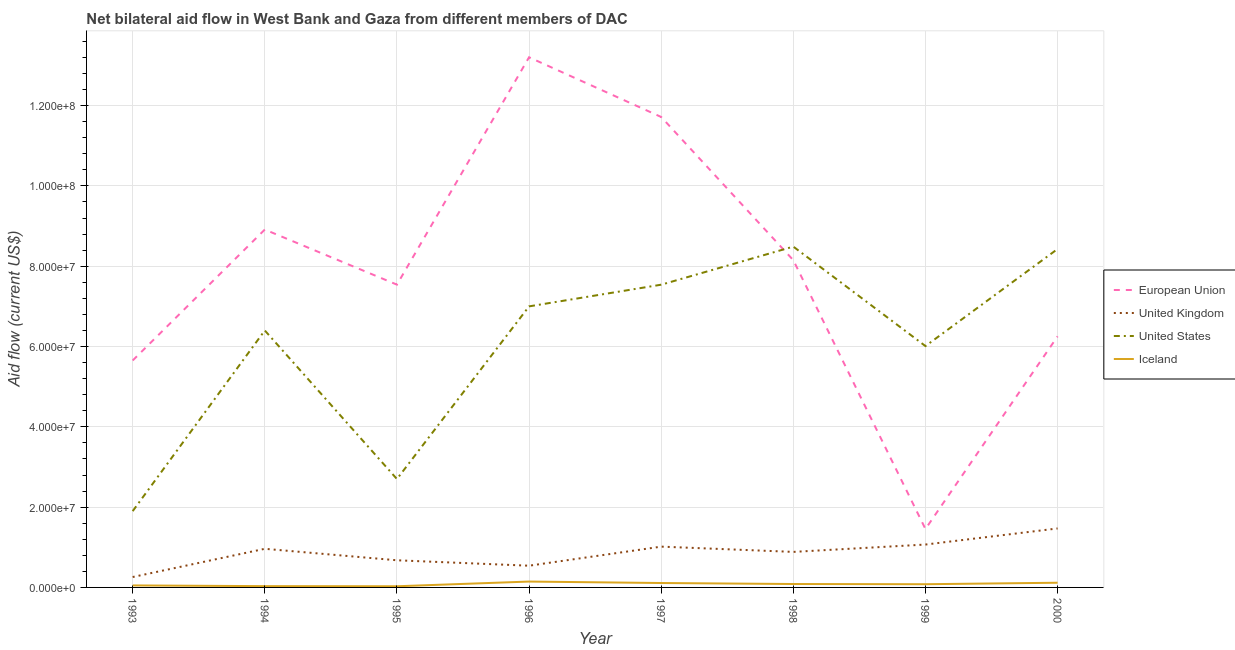Does the line corresponding to amount of aid given by eu intersect with the line corresponding to amount of aid given by iceland?
Your response must be concise. No. Is the number of lines equal to the number of legend labels?
Your answer should be very brief. Yes. What is the amount of aid given by uk in 1997?
Ensure brevity in your answer.  1.02e+07. Across all years, what is the maximum amount of aid given by eu?
Keep it short and to the point. 1.32e+08. Across all years, what is the minimum amount of aid given by uk?
Offer a very short reply. 2.59e+06. In which year was the amount of aid given by eu maximum?
Keep it short and to the point. 1996. In which year was the amount of aid given by iceland minimum?
Offer a very short reply. 1995. What is the total amount of aid given by uk in the graph?
Give a very brief answer. 6.88e+07. What is the difference between the amount of aid given by us in 1994 and that in 1997?
Provide a short and direct response. -1.14e+07. What is the difference between the amount of aid given by uk in 1999 and the amount of aid given by iceland in 1998?
Ensure brevity in your answer.  9.83e+06. What is the average amount of aid given by uk per year?
Keep it short and to the point. 8.60e+06. In the year 1997, what is the difference between the amount of aid given by uk and amount of aid given by us?
Provide a short and direct response. -6.52e+07. What is the ratio of the amount of aid given by us in 1993 to that in 1994?
Offer a very short reply. 0.3. What is the difference between the highest and the second highest amount of aid given by uk?
Your answer should be very brief. 4.01e+06. What is the difference between the highest and the lowest amount of aid given by iceland?
Your answer should be very brief. 1.17e+06. In how many years, is the amount of aid given by eu greater than the average amount of aid given by eu taken over all years?
Keep it short and to the point. 4. Is the sum of the amount of aid given by uk in 1993 and 1996 greater than the maximum amount of aid given by iceland across all years?
Give a very brief answer. Yes. Is it the case that in every year, the sum of the amount of aid given by eu and amount of aid given by uk is greater than the amount of aid given by us?
Offer a very short reply. No. Does the amount of aid given by uk monotonically increase over the years?
Offer a terse response. No. Is the amount of aid given by eu strictly greater than the amount of aid given by us over the years?
Make the answer very short. No. Is the amount of aid given by eu strictly less than the amount of aid given by uk over the years?
Provide a succinct answer. No. How many lines are there?
Offer a terse response. 4. What is the difference between two consecutive major ticks on the Y-axis?
Give a very brief answer. 2.00e+07. Does the graph contain any zero values?
Ensure brevity in your answer.  No. Where does the legend appear in the graph?
Offer a very short reply. Center right. How many legend labels are there?
Make the answer very short. 4. What is the title of the graph?
Keep it short and to the point. Net bilateral aid flow in West Bank and Gaza from different members of DAC. What is the label or title of the Y-axis?
Ensure brevity in your answer.  Aid flow (current US$). What is the Aid flow (current US$) of European Union in 1993?
Provide a succinct answer. 5.65e+07. What is the Aid flow (current US$) of United Kingdom in 1993?
Keep it short and to the point. 2.59e+06. What is the Aid flow (current US$) of United States in 1993?
Keep it short and to the point. 1.90e+07. What is the Aid flow (current US$) in European Union in 1994?
Keep it short and to the point. 8.91e+07. What is the Aid flow (current US$) of United Kingdom in 1994?
Your response must be concise. 9.62e+06. What is the Aid flow (current US$) of United States in 1994?
Offer a very short reply. 6.40e+07. What is the Aid flow (current US$) in European Union in 1995?
Your answer should be compact. 7.54e+07. What is the Aid flow (current US$) of United Kingdom in 1995?
Ensure brevity in your answer.  6.76e+06. What is the Aid flow (current US$) of United States in 1995?
Offer a very short reply. 2.70e+07. What is the Aid flow (current US$) of Iceland in 1995?
Your response must be concise. 2.90e+05. What is the Aid flow (current US$) in European Union in 1996?
Your response must be concise. 1.32e+08. What is the Aid flow (current US$) of United Kingdom in 1996?
Your answer should be very brief. 5.41e+06. What is the Aid flow (current US$) in United States in 1996?
Offer a terse response. 7.00e+07. What is the Aid flow (current US$) of Iceland in 1996?
Your response must be concise. 1.46e+06. What is the Aid flow (current US$) of European Union in 1997?
Ensure brevity in your answer.  1.17e+08. What is the Aid flow (current US$) in United Kingdom in 1997?
Give a very brief answer. 1.02e+07. What is the Aid flow (current US$) in United States in 1997?
Provide a succinct answer. 7.54e+07. What is the Aid flow (current US$) in Iceland in 1997?
Your answer should be very brief. 1.10e+06. What is the Aid flow (current US$) in European Union in 1998?
Make the answer very short. 8.15e+07. What is the Aid flow (current US$) of United Kingdom in 1998?
Offer a very short reply. 8.85e+06. What is the Aid flow (current US$) of United States in 1998?
Keep it short and to the point. 8.49e+07. What is the Aid flow (current US$) of Iceland in 1998?
Provide a short and direct response. 8.50e+05. What is the Aid flow (current US$) in European Union in 1999?
Your response must be concise. 1.46e+07. What is the Aid flow (current US$) in United Kingdom in 1999?
Give a very brief answer. 1.07e+07. What is the Aid flow (current US$) of United States in 1999?
Offer a terse response. 6.01e+07. What is the Aid flow (current US$) of Iceland in 1999?
Your answer should be compact. 8.00e+05. What is the Aid flow (current US$) in European Union in 2000?
Ensure brevity in your answer.  6.25e+07. What is the Aid flow (current US$) in United Kingdom in 2000?
Provide a succinct answer. 1.47e+07. What is the Aid flow (current US$) in United States in 2000?
Your answer should be very brief. 8.43e+07. What is the Aid flow (current US$) in Iceland in 2000?
Provide a succinct answer. 1.17e+06. Across all years, what is the maximum Aid flow (current US$) in European Union?
Offer a terse response. 1.32e+08. Across all years, what is the maximum Aid flow (current US$) of United Kingdom?
Offer a very short reply. 1.47e+07. Across all years, what is the maximum Aid flow (current US$) of United States?
Offer a very short reply. 8.49e+07. Across all years, what is the maximum Aid flow (current US$) in Iceland?
Your answer should be compact. 1.46e+06. Across all years, what is the minimum Aid flow (current US$) of European Union?
Provide a short and direct response. 1.46e+07. Across all years, what is the minimum Aid flow (current US$) of United Kingdom?
Make the answer very short. 2.59e+06. Across all years, what is the minimum Aid flow (current US$) of United States?
Provide a short and direct response. 1.90e+07. Across all years, what is the minimum Aid flow (current US$) in Iceland?
Ensure brevity in your answer.  2.90e+05. What is the total Aid flow (current US$) of European Union in the graph?
Give a very brief answer. 6.29e+08. What is the total Aid flow (current US$) of United Kingdom in the graph?
Provide a succinct answer. 6.88e+07. What is the total Aid flow (current US$) in United States in the graph?
Your answer should be very brief. 4.85e+08. What is the total Aid flow (current US$) in Iceland in the graph?
Make the answer very short. 6.49e+06. What is the difference between the Aid flow (current US$) of European Union in 1993 and that in 1994?
Your response must be concise. -3.26e+07. What is the difference between the Aid flow (current US$) of United Kingdom in 1993 and that in 1994?
Give a very brief answer. -7.03e+06. What is the difference between the Aid flow (current US$) of United States in 1993 and that in 1994?
Offer a very short reply. -4.50e+07. What is the difference between the Aid flow (current US$) of Iceland in 1993 and that in 1994?
Ensure brevity in your answer.  1.80e+05. What is the difference between the Aid flow (current US$) in European Union in 1993 and that in 1995?
Provide a short and direct response. -1.89e+07. What is the difference between the Aid flow (current US$) in United Kingdom in 1993 and that in 1995?
Ensure brevity in your answer.  -4.17e+06. What is the difference between the Aid flow (current US$) in United States in 1993 and that in 1995?
Keep it short and to the point. -8.00e+06. What is the difference between the Aid flow (current US$) of Iceland in 1993 and that in 1995?
Make the answer very short. 2.10e+05. What is the difference between the Aid flow (current US$) in European Union in 1993 and that in 1996?
Make the answer very short. -7.55e+07. What is the difference between the Aid flow (current US$) of United Kingdom in 1993 and that in 1996?
Your answer should be very brief. -2.82e+06. What is the difference between the Aid flow (current US$) in United States in 1993 and that in 1996?
Provide a succinct answer. -5.10e+07. What is the difference between the Aid flow (current US$) in Iceland in 1993 and that in 1996?
Provide a short and direct response. -9.60e+05. What is the difference between the Aid flow (current US$) in European Union in 1993 and that in 1997?
Give a very brief answer. -6.06e+07. What is the difference between the Aid flow (current US$) in United Kingdom in 1993 and that in 1997?
Your answer should be very brief. -7.57e+06. What is the difference between the Aid flow (current US$) of United States in 1993 and that in 1997?
Provide a short and direct response. -5.64e+07. What is the difference between the Aid flow (current US$) of Iceland in 1993 and that in 1997?
Your answer should be very brief. -6.00e+05. What is the difference between the Aid flow (current US$) of European Union in 1993 and that in 1998?
Offer a very short reply. -2.50e+07. What is the difference between the Aid flow (current US$) in United Kingdom in 1993 and that in 1998?
Give a very brief answer. -6.26e+06. What is the difference between the Aid flow (current US$) in United States in 1993 and that in 1998?
Offer a very short reply. -6.59e+07. What is the difference between the Aid flow (current US$) in Iceland in 1993 and that in 1998?
Keep it short and to the point. -3.50e+05. What is the difference between the Aid flow (current US$) of European Union in 1993 and that in 1999?
Offer a very short reply. 4.20e+07. What is the difference between the Aid flow (current US$) of United Kingdom in 1993 and that in 1999?
Your answer should be very brief. -8.09e+06. What is the difference between the Aid flow (current US$) in United States in 1993 and that in 1999?
Offer a very short reply. -4.11e+07. What is the difference between the Aid flow (current US$) of Iceland in 1993 and that in 1999?
Provide a succinct answer. -3.00e+05. What is the difference between the Aid flow (current US$) of European Union in 1993 and that in 2000?
Offer a very short reply. -6.01e+06. What is the difference between the Aid flow (current US$) of United Kingdom in 1993 and that in 2000?
Provide a succinct answer. -1.21e+07. What is the difference between the Aid flow (current US$) of United States in 1993 and that in 2000?
Ensure brevity in your answer.  -6.53e+07. What is the difference between the Aid flow (current US$) of Iceland in 1993 and that in 2000?
Ensure brevity in your answer.  -6.70e+05. What is the difference between the Aid flow (current US$) in European Union in 1994 and that in 1995?
Your answer should be very brief. 1.37e+07. What is the difference between the Aid flow (current US$) in United Kingdom in 1994 and that in 1995?
Provide a succinct answer. 2.86e+06. What is the difference between the Aid flow (current US$) of United States in 1994 and that in 1995?
Provide a short and direct response. 3.70e+07. What is the difference between the Aid flow (current US$) of Iceland in 1994 and that in 1995?
Make the answer very short. 3.00e+04. What is the difference between the Aid flow (current US$) in European Union in 1994 and that in 1996?
Your answer should be compact. -4.29e+07. What is the difference between the Aid flow (current US$) in United Kingdom in 1994 and that in 1996?
Provide a succinct answer. 4.21e+06. What is the difference between the Aid flow (current US$) of United States in 1994 and that in 1996?
Keep it short and to the point. -6.00e+06. What is the difference between the Aid flow (current US$) in Iceland in 1994 and that in 1996?
Ensure brevity in your answer.  -1.14e+06. What is the difference between the Aid flow (current US$) of European Union in 1994 and that in 1997?
Make the answer very short. -2.80e+07. What is the difference between the Aid flow (current US$) of United Kingdom in 1994 and that in 1997?
Provide a short and direct response. -5.40e+05. What is the difference between the Aid flow (current US$) in United States in 1994 and that in 1997?
Your answer should be very brief. -1.14e+07. What is the difference between the Aid flow (current US$) of Iceland in 1994 and that in 1997?
Give a very brief answer. -7.80e+05. What is the difference between the Aid flow (current US$) of European Union in 1994 and that in 1998?
Your response must be concise. 7.63e+06. What is the difference between the Aid flow (current US$) of United Kingdom in 1994 and that in 1998?
Make the answer very short. 7.70e+05. What is the difference between the Aid flow (current US$) of United States in 1994 and that in 1998?
Make the answer very short. -2.09e+07. What is the difference between the Aid flow (current US$) of Iceland in 1994 and that in 1998?
Give a very brief answer. -5.30e+05. What is the difference between the Aid flow (current US$) of European Union in 1994 and that in 1999?
Your answer should be compact. 7.46e+07. What is the difference between the Aid flow (current US$) of United Kingdom in 1994 and that in 1999?
Your answer should be compact. -1.06e+06. What is the difference between the Aid flow (current US$) in United States in 1994 and that in 1999?
Make the answer very short. 3.89e+06. What is the difference between the Aid flow (current US$) of Iceland in 1994 and that in 1999?
Provide a short and direct response. -4.80e+05. What is the difference between the Aid flow (current US$) in European Union in 1994 and that in 2000?
Provide a short and direct response. 2.66e+07. What is the difference between the Aid flow (current US$) in United Kingdom in 1994 and that in 2000?
Keep it short and to the point. -5.07e+06. What is the difference between the Aid flow (current US$) of United States in 1994 and that in 2000?
Make the answer very short. -2.03e+07. What is the difference between the Aid flow (current US$) of Iceland in 1994 and that in 2000?
Provide a succinct answer. -8.50e+05. What is the difference between the Aid flow (current US$) in European Union in 1995 and that in 1996?
Keep it short and to the point. -5.66e+07. What is the difference between the Aid flow (current US$) in United Kingdom in 1995 and that in 1996?
Provide a short and direct response. 1.35e+06. What is the difference between the Aid flow (current US$) in United States in 1995 and that in 1996?
Make the answer very short. -4.30e+07. What is the difference between the Aid flow (current US$) in Iceland in 1995 and that in 1996?
Provide a short and direct response. -1.17e+06. What is the difference between the Aid flow (current US$) in European Union in 1995 and that in 1997?
Give a very brief answer. -4.18e+07. What is the difference between the Aid flow (current US$) of United Kingdom in 1995 and that in 1997?
Ensure brevity in your answer.  -3.40e+06. What is the difference between the Aid flow (current US$) in United States in 1995 and that in 1997?
Your response must be concise. -4.84e+07. What is the difference between the Aid flow (current US$) of Iceland in 1995 and that in 1997?
Your response must be concise. -8.10e+05. What is the difference between the Aid flow (current US$) in European Union in 1995 and that in 1998?
Your response must be concise. -6.09e+06. What is the difference between the Aid flow (current US$) of United Kingdom in 1995 and that in 1998?
Offer a very short reply. -2.09e+06. What is the difference between the Aid flow (current US$) of United States in 1995 and that in 1998?
Provide a short and direct response. -5.79e+07. What is the difference between the Aid flow (current US$) in Iceland in 1995 and that in 1998?
Give a very brief answer. -5.60e+05. What is the difference between the Aid flow (current US$) of European Union in 1995 and that in 1999?
Keep it short and to the point. 6.09e+07. What is the difference between the Aid flow (current US$) in United Kingdom in 1995 and that in 1999?
Provide a short and direct response. -3.92e+06. What is the difference between the Aid flow (current US$) in United States in 1995 and that in 1999?
Your answer should be compact. -3.31e+07. What is the difference between the Aid flow (current US$) of Iceland in 1995 and that in 1999?
Keep it short and to the point. -5.10e+05. What is the difference between the Aid flow (current US$) of European Union in 1995 and that in 2000?
Give a very brief answer. 1.29e+07. What is the difference between the Aid flow (current US$) in United Kingdom in 1995 and that in 2000?
Ensure brevity in your answer.  -7.93e+06. What is the difference between the Aid flow (current US$) of United States in 1995 and that in 2000?
Offer a very short reply. -5.73e+07. What is the difference between the Aid flow (current US$) in Iceland in 1995 and that in 2000?
Ensure brevity in your answer.  -8.80e+05. What is the difference between the Aid flow (current US$) of European Union in 1996 and that in 1997?
Your answer should be compact. 1.49e+07. What is the difference between the Aid flow (current US$) of United Kingdom in 1996 and that in 1997?
Give a very brief answer. -4.75e+06. What is the difference between the Aid flow (current US$) of United States in 1996 and that in 1997?
Offer a very short reply. -5.40e+06. What is the difference between the Aid flow (current US$) in Iceland in 1996 and that in 1997?
Your answer should be compact. 3.60e+05. What is the difference between the Aid flow (current US$) of European Union in 1996 and that in 1998?
Make the answer very short. 5.05e+07. What is the difference between the Aid flow (current US$) in United Kingdom in 1996 and that in 1998?
Your response must be concise. -3.44e+06. What is the difference between the Aid flow (current US$) in United States in 1996 and that in 1998?
Make the answer very short. -1.49e+07. What is the difference between the Aid flow (current US$) of Iceland in 1996 and that in 1998?
Ensure brevity in your answer.  6.10e+05. What is the difference between the Aid flow (current US$) of European Union in 1996 and that in 1999?
Provide a succinct answer. 1.17e+08. What is the difference between the Aid flow (current US$) of United Kingdom in 1996 and that in 1999?
Offer a terse response. -5.27e+06. What is the difference between the Aid flow (current US$) of United States in 1996 and that in 1999?
Give a very brief answer. 9.89e+06. What is the difference between the Aid flow (current US$) of Iceland in 1996 and that in 1999?
Provide a succinct answer. 6.60e+05. What is the difference between the Aid flow (current US$) of European Union in 1996 and that in 2000?
Make the answer very short. 6.95e+07. What is the difference between the Aid flow (current US$) in United Kingdom in 1996 and that in 2000?
Provide a short and direct response. -9.28e+06. What is the difference between the Aid flow (current US$) of United States in 1996 and that in 2000?
Offer a terse response. -1.43e+07. What is the difference between the Aid flow (current US$) of Iceland in 1996 and that in 2000?
Offer a very short reply. 2.90e+05. What is the difference between the Aid flow (current US$) in European Union in 1997 and that in 1998?
Offer a terse response. 3.57e+07. What is the difference between the Aid flow (current US$) in United Kingdom in 1997 and that in 1998?
Give a very brief answer. 1.31e+06. What is the difference between the Aid flow (current US$) in United States in 1997 and that in 1998?
Give a very brief answer. -9.48e+06. What is the difference between the Aid flow (current US$) of Iceland in 1997 and that in 1998?
Ensure brevity in your answer.  2.50e+05. What is the difference between the Aid flow (current US$) in European Union in 1997 and that in 1999?
Provide a short and direct response. 1.03e+08. What is the difference between the Aid flow (current US$) in United Kingdom in 1997 and that in 1999?
Give a very brief answer. -5.20e+05. What is the difference between the Aid flow (current US$) of United States in 1997 and that in 1999?
Offer a very short reply. 1.53e+07. What is the difference between the Aid flow (current US$) in European Union in 1997 and that in 2000?
Keep it short and to the point. 5.46e+07. What is the difference between the Aid flow (current US$) of United Kingdom in 1997 and that in 2000?
Your answer should be very brief. -4.53e+06. What is the difference between the Aid flow (current US$) in United States in 1997 and that in 2000?
Provide a succinct answer. -8.89e+06. What is the difference between the Aid flow (current US$) in Iceland in 1997 and that in 2000?
Ensure brevity in your answer.  -7.00e+04. What is the difference between the Aid flow (current US$) in European Union in 1998 and that in 1999?
Your response must be concise. 6.70e+07. What is the difference between the Aid flow (current US$) of United Kingdom in 1998 and that in 1999?
Keep it short and to the point. -1.83e+06. What is the difference between the Aid flow (current US$) of United States in 1998 and that in 1999?
Make the answer very short. 2.48e+07. What is the difference between the Aid flow (current US$) of European Union in 1998 and that in 2000?
Make the answer very short. 1.90e+07. What is the difference between the Aid flow (current US$) in United Kingdom in 1998 and that in 2000?
Your response must be concise. -5.84e+06. What is the difference between the Aid flow (current US$) of United States in 1998 and that in 2000?
Your answer should be very brief. 5.90e+05. What is the difference between the Aid flow (current US$) of Iceland in 1998 and that in 2000?
Provide a short and direct response. -3.20e+05. What is the difference between the Aid flow (current US$) of European Union in 1999 and that in 2000?
Your answer should be very brief. -4.80e+07. What is the difference between the Aid flow (current US$) of United Kingdom in 1999 and that in 2000?
Give a very brief answer. -4.01e+06. What is the difference between the Aid flow (current US$) of United States in 1999 and that in 2000?
Offer a terse response. -2.42e+07. What is the difference between the Aid flow (current US$) in Iceland in 1999 and that in 2000?
Your response must be concise. -3.70e+05. What is the difference between the Aid flow (current US$) in European Union in 1993 and the Aid flow (current US$) in United Kingdom in 1994?
Keep it short and to the point. 4.69e+07. What is the difference between the Aid flow (current US$) of European Union in 1993 and the Aid flow (current US$) of United States in 1994?
Ensure brevity in your answer.  -7.48e+06. What is the difference between the Aid flow (current US$) of European Union in 1993 and the Aid flow (current US$) of Iceland in 1994?
Your response must be concise. 5.62e+07. What is the difference between the Aid flow (current US$) of United Kingdom in 1993 and the Aid flow (current US$) of United States in 1994?
Your answer should be very brief. -6.14e+07. What is the difference between the Aid flow (current US$) of United Kingdom in 1993 and the Aid flow (current US$) of Iceland in 1994?
Offer a very short reply. 2.27e+06. What is the difference between the Aid flow (current US$) of United States in 1993 and the Aid flow (current US$) of Iceland in 1994?
Offer a very short reply. 1.87e+07. What is the difference between the Aid flow (current US$) of European Union in 1993 and the Aid flow (current US$) of United Kingdom in 1995?
Give a very brief answer. 4.98e+07. What is the difference between the Aid flow (current US$) in European Union in 1993 and the Aid flow (current US$) in United States in 1995?
Keep it short and to the point. 2.95e+07. What is the difference between the Aid flow (current US$) of European Union in 1993 and the Aid flow (current US$) of Iceland in 1995?
Your answer should be very brief. 5.62e+07. What is the difference between the Aid flow (current US$) of United Kingdom in 1993 and the Aid flow (current US$) of United States in 1995?
Provide a succinct answer. -2.44e+07. What is the difference between the Aid flow (current US$) of United Kingdom in 1993 and the Aid flow (current US$) of Iceland in 1995?
Your response must be concise. 2.30e+06. What is the difference between the Aid flow (current US$) of United States in 1993 and the Aid flow (current US$) of Iceland in 1995?
Offer a terse response. 1.87e+07. What is the difference between the Aid flow (current US$) in European Union in 1993 and the Aid flow (current US$) in United Kingdom in 1996?
Offer a very short reply. 5.11e+07. What is the difference between the Aid flow (current US$) in European Union in 1993 and the Aid flow (current US$) in United States in 1996?
Your answer should be compact. -1.35e+07. What is the difference between the Aid flow (current US$) of European Union in 1993 and the Aid flow (current US$) of Iceland in 1996?
Offer a very short reply. 5.51e+07. What is the difference between the Aid flow (current US$) in United Kingdom in 1993 and the Aid flow (current US$) in United States in 1996?
Provide a short and direct response. -6.74e+07. What is the difference between the Aid flow (current US$) of United Kingdom in 1993 and the Aid flow (current US$) of Iceland in 1996?
Your answer should be very brief. 1.13e+06. What is the difference between the Aid flow (current US$) in United States in 1993 and the Aid flow (current US$) in Iceland in 1996?
Provide a short and direct response. 1.75e+07. What is the difference between the Aid flow (current US$) in European Union in 1993 and the Aid flow (current US$) in United Kingdom in 1997?
Offer a very short reply. 4.64e+07. What is the difference between the Aid flow (current US$) of European Union in 1993 and the Aid flow (current US$) of United States in 1997?
Your answer should be very brief. -1.89e+07. What is the difference between the Aid flow (current US$) in European Union in 1993 and the Aid flow (current US$) in Iceland in 1997?
Offer a terse response. 5.54e+07. What is the difference between the Aid flow (current US$) of United Kingdom in 1993 and the Aid flow (current US$) of United States in 1997?
Make the answer very short. -7.28e+07. What is the difference between the Aid flow (current US$) of United Kingdom in 1993 and the Aid flow (current US$) of Iceland in 1997?
Ensure brevity in your answer.  1.49e+06. What is the difference between the Aid flow (current US$) in United States in 1993 and the Aid flow (current US$) in Iceland in 1997?
Your response must be concise. 1.79e+07. What is the difference between the Aid flow (current US$) in European Union in 1993 and the Aid flow (current US$) in United Kingdom in 1998?
Offer a very short reply. 4.77e+07. What is the difference between the Aid flow (current US$) in European Union in 1993 and the Aid flow (current US$) in United States in 1998?
Offer a terse response. -2.84e+07. What is the difference between the Aid flow (current US$) in European Union in 1993 and the Aid flow (current US$) in Iceland in 1998?
Ensure brevity in your answer.  5.57e+07. What is the difference between the Aid flow (current US$) in United Kingdom in 1993 and the Aid flow (current US$) in United States in 1998?
Provide a short and direct response. -8.23e+07. What is the difference between the Aid flow (current US$) in United Kingdom in 1993 and the Aid flow (current US$) in Iceland in 1998?
Keep it short and to the point. 1.74e+06. What is the difference between the Aid flow (current US$) of United States in 1993 and the Aid flow (current US$) of Iceland in 1998?
Give a very brief answer. 1.82e+07. What is the difference between the Aid flow (current US$) of European Union in 1993 and the Aid flow (current US$) of United Kingdom in 1999?
Provide a short and direct response. 4.58e+07. What is the difference between the Aid flow (current US$) of European Union in 1993 and the Aid flow (current US$) of United States in 1999?
Your answer should be very brief. -3.59e+06. What is the difference between the Aid flow (current US$) of European Union in 1993 and the Aid flow (current US$) of Iceland in 1999?
Offer a very short reply. 5.57e+07. What is the difference between the Aid flow (current US$) of United Kingdom in 1993 and the Aid flow (current US$) of United States in 1999?
Your response must be concise. -5.75e+07. What is the difference between the Aid flow (current US$) in United Kingdom in 1993 and the Aid flow (current US$) in Iceland in 1999?
Provide a short and direct response. 1.79e+06. What is the difference between the Aid flow (current US$) of United States in 1993 and the Aid flow (current US$) of Iceland in 1999?
Give a very brief answer. 1.82e+07. What is the difference between the Aid flow (current US$) of European Union in 1993 and the Aid flow (current US$) of United Kingdom in 2000?
Your answer should be very brief. 4.18e+07. What is the difference between the Aid flow (current US$) in European Union in 1993 and the Aid flow (current US$) in United States in 2000?
Your answer should be compact. -2.78e+07. What is the difference between the Aid flow (current US$) of European Union in 1993 and the Aid flow (current US$) of Iceland in 2000?
Offer a terse response. 5.54e+07. What is the difference between the Aid flow (current US$) in United Kingdom in 1993 and the Aid flow (current US$) in United States in 2000?
Your response must be concise. -8.17e+07. What is the difference between the Aid flow (current US$) of United Kingdom in 1993 and the Aid flow (current US$) of Iceland in 2000?
Your response must be concise. 1.42e+06. What is the difference between the Aid flow (current US$) in United States in 1993 and the Aid flow (current US$) in Iceland in 2000?
Give a very brief answer. 1.78e+07. What is the difference between the Aid flow (current US$) in European Union in 1994 and the Aid flow (current US$) in United Kingdom in 1995?
Your answer should be very brief. 8.24e+07. What is the difference between the Aid flow (current US$) of European Union in 1994 and the Aid flow (current US$) of United States in 1995?
Provide a succinct answer. 6.21e+07. What is the difference between the Aid flow (current US$) in European Union in 1994 and the Aid flow (current US$) in Iceland in 1995?
Offer a very short reply. 8.88e+07. What is the difference between the Aid flow (current US$) of United Kingdom in 1994 and the Aid flow (current US$) of United States in 1995?
Make the answer very short. -1.74e+07. What is the difference between the Aid flow (current US$) in United Kingdom in 1994 and the Aid flow (current US$) in Iceland in 1995?
Give a very brief answer. 9.33e+06. What is the difference between the Aid flow (current US$) of United States in 1994 and the Aid flow (current US$) of Iceland in 1995?
Make the answer very short. 6.37e+07. What is the difference between the Aid flow (current US$) of European Union in 1994 and the Aid flow (current US$) of United Kingdom in 1996?
Keep it short and to the point. 8.37e+07. What is the difference between the Aid flow (current US$) of European Union in 1994 and the Aid flow (current US$) of United States in 1996?
Your response must be concise. 1.91e+07. What is the difference between the Aid flow (current US$) in European Union in 1994 and the Aid flow (current US$) in Iceland in 1996?
Provide a short and direct response. 8.77e+07. What is the difference between the Aid flow (current US$) in United Kingdom in 1994 and the Aid flow (current US$) in United States in 1996?
Your answer should be very brief. -6.04e+07. What is the difference between the Aid flow (current US$) of United Kingdom in 1994 and the Aid flow (current US$) of Iceland in 1996?
Offer a very short reply. 8.16e+06. What is the difference between the Aid flow (current US$) of United States in 1994 and the Aid flow (current US$) of Iceland in 1996?
Your answer should be compact. 6.25e+07. What is the difference between the Aid flow (current US$) in European Union in 1994 and the Aid flow (current US$) in United Kingdom in 1997?
Your answer should be compact. 7.90e+07. What is the difference between the Aid flow (current US$) in European Union in 1994 and the Aid flow (current US$) in United States in 1997?
Ensure brevity in your answer.  1.37e+07. What is the difference between the Aid flow (current US$) of European Union in 1994 and the Aid flow (current US$) of Iceland in 1997?
Provide a succinct answer. 8.80e+07. What is the difference between the Aid flow (current US$) in United Kingdom in 1994 and the Aid flow (current US$) in United States in 1997?
Give a very brief answer. -6.58e+07. What is the difference between the Aid flow (current US$) in United Kingdom in 1994 and the Aid flow (current US$) in Iceland in 1997?
Offer a terse response. 8.52e+06. What is the difference between the Aid flow (current US$) of United States in 1994 and the Aid flow (current US$) of Iceland in 1997?
Provide a succinct answer. 6.29e+07. What is the difference between the Aid flow (current US$) of European Union in 1994 and the Aid flow (current US$) of United Kingdom in 1998?
Give a very brief answer. 8.03e+07. What is the difference between the Aid flow (current US$) in European Union in 1994 and the Aid flow (current US$) in United States in 1998?
Offer a terse response. 4.25e+06. What is the difference between the Aid flow (current US$) in European Union in 1994 and the Aid flow (current US$) in Iceland in 1998?
Make the answer very short. 8.83e+07. What is the difference between the Aid flow (current US$) in United Kingdom in 1994 and the Aid flow (current US$) in United States in 1998?
Your answer should be very brief. -7.53e+07. What is the difference between the Aid flow (current US$) of United Kingdom in 1994 and the Aid flow (current US$) of Iceland in 1998?
Provide a short and direct response. 8.77e+06. What is the difference between the Aid flow (current US$) in United States in 1994 and the Aid flow (current US$) in Iceland in 1998?
Offer a very short reply. 6.32e+07. What is the difference between the Aid flow (current US$) of European Union in 1994 and the Aid flow (current US$) of United Kingdom in 1999?
Your response must be concise. 7.84e+07. What is the difference between the Aid flow (current US$) of European Union in 1994 and the Aid flow (current US$) of United States in 1999?
Offer a very short reply. 2.90e+07. What is the difference between the Aid flow (current US$) in European Union in 1994 and the Aid flow (current US$) in Iceland in 1999?
Ensure brevity in your answer.  8.83e+07. What is the difference between the Aid flow (current US$) in United Kingdom in 1994 and the Aid flow (current US$) in United States in 1999?
Provide a succinct answer. -5.05e+07. What is the difference between the Aid flow (current US$) of United Kingdom in 1994 and the Aid flow (current US$) of Iceland in 1999?
Provide a succinct answer. 8.82e+06. What is the difference between the Aid flow (current US$) in United States in 1994 and the Aid flow (current US$) in Iceland in 1999?
Give a very brief answer. 6.32e+07. What is the difference between the Aid flow (current US$) in European Union in 1994 and the Aid flow (current US$) in United Kingdom in 2000?
Your response must be concise. 7.44e+07. What is the difference between the Aid flow (current US$) in European Union in 1994 and the Aid flow (current US$) in United States in 2000?
Offer a very short reply. 4.84e+06. What is the difference between the Aid flow (current US$) of European Union in 1994 and the Aid flow (current US$) of Iceland in 2000?
Your response must be concise. 8.80e+07. What is the difference between the Aid flow (current US$) of United Kingdom in 1994 and the Aid flow (current US$) of United States in 2000?
Provide a succinct answer. -7.47e+07. What is the difference between the Aid flow (current US$) of United Kingdom in 1994 and the Aid flow (current US$) of Iceland in 2000?
Your answer should be compact. 8.45e+06. What is the difference between the Aid flow (current US$) of United States in 1994 and the Aid flow (current US$) of Iceland in 2000?
Offer a very short reply. 6.28e+07. What is the difference between the Aid flow (current US$) in European Union in 1995 and the Aid flow (current US$) in United Kingdom in 1996?
Your answer should be compact. 7.00e+07. What is the difference between the Aid flow (current US$) of European Union in 1995 and the Aid flow (current US$) of United States in 1996?
Provide a short and direct response. 5.41e+06. What is the difference between the Aid flow (current US$) of European Union in 1995 and the Aid flow (current US$) of Iceland in 1996?
Give a very brief answer. 7.40e+07. What is the difference between the Aid flow (current US$) of United Kingdom in 1995 and the Aid flow (current US$) of United States in 1996?
Your response must be concise. -6.32e+07. What is the difference between the Aid flow (current US$) of United Kingdom in 1995 and the Aid flow (current US$) of Iceland in 1996?
Your answer should be compact. 5.30e+06. What is the difference between the Aid flow (current US$) of United States in 1995 and the Aid flow (current US$) of Iceland in 1996?
Your response must be concise. 2.55e+07. What is the difference between the Aid flow (current US$) in European Union in 1995 and the Aid flow (current US$) in United Kingdom in 1997?
Offer a terse response. 6.52e+07. What is the difference between the Aid flow (current US$) in European Union in 1995 and the Aid flow (current US$) in Iceland in 1997?
Your answer should be compact. 7.43e+07. What is the difference between the Aid flow (current US$) of United Kingdom in 1995 and the Aid flow (current US$) of United States in 1997?
Offer a very short reply. -6.86e+07. What is the difference between the Aid flow (current US$) in United Kingdom in 1995 and the Aid flow (current US$) in Iceland in 1997?
Give a very brief answer. 5.66e+06. What is the difference between the Aid flow (current US$) in United States in 1995 and the Aid flow (current US$) in Iceland in 1997?
Provide a short and direct response. 2.59e+07. What is the difference between the Aid flow (current US$) of European Union in 1995 and the Aid flow (current US$) of United Kingdom in 1998?
Offer a very short reply. 6.66e+07. What is the difference between the Aid flow (current US$) in European Union in 1995 and the Aid flow (current US$) in United States in 1998?
Your answer should be compact. -9.47e+06. What is the difference between the Aid flow (current US$) of European Union in 1995 and the Aid flow (current US$) of Iceland in 1998?
Make the answer very short. 7.46e+07. What is the difference between the Aid flow (current US$) of United Kingdom in 1995 and the Aid flow (current US$) of United States in 1998?
Your response must be concise. -7.81e+07. What is the difference between the Aid flow (current US$) in United Kingdom in 1995 and the Aid flow (current US$) in Iceland in 1998?
Your response must be concise. 5.91e+06. What is the difference between the Aid flow (current US$) in United States in 1995 and the Aid flow (current US$) in Iceland in 1998?
Provide a succinct answer. 2.62e+07. What is the difference between the Aid flow (current US$) in European Union in 1995 and the Aid flow (current US$) in United Kingdom in 1999?
Your answer should be very brief. 6.47e+07. What is the difference between the Aid flow (current US$) of European Union in 1995 and the Aid flow (current US$) of United States in 1999?
Give a very brief answer. 1.53e+07. What is the difference between the Aid flow (current US$) in European Union in 1995 and the Aid flow (current US$) in Iceland in 1999?
Ensure brevity in your answer.  7.46e+07. What is the difference between the Aid flow (current US$) in United Kingdom in 1995 and the Aid flow (current US$) in United States in 1999?
Your answer should be compact. -5.34e+07. What is the difference between the Aid flow (current US$) in United Kingdom in 1995 and the Aid flow (current US$) in Iceland in 1999?
Your response must be concise. 5.96e+06. What is the difference between the Aid flow (current US$) of United States in 1995 and the Aid flow (current US$) of Iceland in 1999?
Offer a terse response. 2.62e+07. What is the difference between the Aid flow (current US$) of European Union in 1995 and the Aid flow (current US$) of United Kingdom in 2000?
Provide a succinct answer. 6.07e+07. What is the difference between the Aid flow (current US$) in European Union in 1995 and the Aid flow (current US$) in United States in 2000?
Your answer should be compact. -8.88e+06. What is the difference between the Aid flow (current US$) in European Union in 1995 and the Aid flow (current US$) in Iceland in 2000?
Offer a terse response. 7.42e+07. What is the difference between the Aid flow (current US$) of United Kingdom in 1995 and the Aid flow (current US$) of United States in 2000?
Give a very brief answer. -7.75e+07. What is the difference between the Aid flow (current US$) of United Kingdom in 1995 and the Aid flow (current US$) of Iceland in 2000?
Your answer should be compact. 5.59e+06. What is the difference between the Aid flow (current US$) in United States in 1995 and the Aid flow (current US$) in Iceland in 2000?
Provide a short and direct response. 2.58e+07. What is the difference between the Aid flow (current US$) of European Union in 1996 and the Aid flow (current US$) of United Kingdom in 1997?
Keep it short and to the point. 1.22e+08. What is the difference between the Aid flow (current US$) of European Union in 1996 and the Aid flow (current US$) of United States in 1997?
Offer a very short reply. 5.66e+07. What is the difference between the Aid flow (current US$) of European Union in 1996 and the Aid flow (current US$) of Iceland in 1997?
Offer a terse response. 1.31e+08. What is the difference between the Aid flow (current US$) of United Kingdom in 1996 and the Aid flow (current US$) of United States in 1997?
Make the answer very short. -7.00e+07. What is the difference between the Aid flow (current US$) of United Kingdom in 1996 and the Aid flow (current US$) of Iceland in 1997?
Make the answer very short. 4.31e+06. What is the difference between the Aid flow (current US$) in United States in 1996 and the Aid flow (current US$) in Iceland in 1997?
Your answer should be compact. 6.89e+07. What is the difference between the Aid flow (current US$) in European Union in 1996 and the Aid flow (current US$) in United Kingdom in 1998?
Keep it short and to the point. 1.23e+08. What is the difference between the Aid flow (current US$) in European Union in 1996 and the Aid flow (current US$) in United States in 1998?
Your response must be concise. 4.72e+07. What is the difference between the Aid flow (current US$) in European Union in 1996 and the Aid flow (current US$) in Iceland in 1998?
Your answer should be very brief. 1.31e+08. What is the difference between the Aid flow (current US$) of United Kingdom in 1996 and the Aid flow (current US$) of United States in 1998?
Provide a short and direct response. -7.95e+07. What is the difference between the Aid flow (current US$) of United Kingdom in 1996 and the Aid flow (current US$) of Iceland in 1998?
Ensure brevity in your answer.  4.56e+06. What is the difference between the Aid flow (current US$) in United States in 1996 and the Aid flow (current US$) in Iceland in 1998?
Provide a short and direct response. 6.92e+07. What is the difference between the Aid flow (current US$) of European Union in 1996 and the Aid flow (current US$) of United Kingdom in 1999?
Make the answer very short. 1.21e+08. What is the difference between the Aid flow (current US$) in European Union in 1996 and the Aid flow (current US$) in United States in 1999?
Offer a terse response. 7.19e+07. What is the difference between the Aid flow (current US$) in European Union in 1996 and the Aid flow (current US$) in Iceland in 1999?
Provide a short and direct response. 1.31e+08. What is the difference between the Aid flow (current US$) of United Kingdom in 1996 and the Aid flow (current US$) of United States in 1999?
Make the answer very short. -5.47e+07. What is the difference between the Aid flow (current US$) of United Kingdom in 1996 and the Aid flow (current US$) of Iceland in 1999?
Provide a short and direct response. 4.61e+06. What is the difference between the Aid flow (current US$) in United States in 1996 and the Aid flow (current US$) in Iceland in 1999?
Ensure brevity in your answer.  6.92e+07. What is the difference between the Aid flow (current US$) of European Union in 1996 and the Aid flow (current US$) of United Kingdom in 2000?
Your answer should be very brief. 1.17e+08. What is the difference between the Aid flow (current US$) of European Union in 1996 and the Aid flow (current US$) of United States in 2000?
Provide a short and direct response. 4.78e+07. What is the difference between the Aid flow (current US$) of European Union in 1996 and the Aid flow (current US$) of Iceland in 2000?
Give a very brief answer. 1.31e+08. What is the difference between the Aid flow (current US$) of United Kingdom in 1996 and the Aid flow (current US$) of United States in 2000?
Keep it short and to the point. -7.89e+07. What is the difference between the Aid flow (current US$) in United Kingdom in 1996 and the Aid flow (current US$) in Iceland in 2000?
Offer a very short reply. 4.24e+06. What is the difference between the Aid flow (current US$) of United States in 1996 and the Aid flow (current US$) of Iceland in 2000?
Offer a very short reply. 6.88e+07. What is the difference between the Aid flow (current US$) in European Union in 1997 and the Aid flow (current US$) in United Kingdom in 1998?
Your answer should be compact. 1.08e+08. What is the difference between the Aid flow (current US$) of European Union in 1997 and the Aid flow (current US$) of United States in 1998?
Provide a succinct answer. 3.23e+07. What is the difference between the Aid flow (current US$) of European Union in 1997 and the Aid flow (current US$) of Iceland in 1998?
Keep it short and to the point. 1.16e+08. What is the difference between the Aid flow (current US$) in United Kingdom in 1997 and the Aid flow (current US$) in United States in 1998?
Provide a short and direct response. -7.47e+07. What is the difference between the Aid flow (current US$) of United Kingdom in 1997 and the Aid flow (current US$) of Iceland in 1998?
Make the answer very short. 9.31e+06. What is the difference between the Aid flow (current US$) of United States in 1997 and the Aid flow (current US$) of Iceland in 1998?
Provide a succinct answer. 7.46e+07. What is the difference between the Aid flow (current US$) of European Union in 1997 and the Aid flow (current US$) of United Kingdom in 1999?
Offer a terse response. 1.06e+08. What is the difference between the Aid flow (current US$) in European Union in 1997 and the Aid flow (current US$) in United States in 1999?
Provide a succinct answer. 5.71e+07. What is the difference between the Aid flow (current US$) of European Union in 1997 and the Aid flow (current US$) of Iceland in 1999?
Your response must be concise. 1.16e+08. What is the difference between the Aid flow (current US$) of United Kingdom in 1997 and the Aid flow (current US$) of United States in 1999?
Give a very brief answer. -5.00e+07. What is the difference between the Aid flow (current US$) of United Kingdom in 1997 and the Aid flow (current US$) of Iceland in 1999?
Make the answer very short. 9.36e+06. What is the difference between the Aid flow (current US$) of United States in 1997 and the Aid flow (current US$) of Iceland in 1999?
Provide a short and direct response. 7.46e+07. What is the difference between the Aid flow (current US$) in European Union in 1997 and the Aid flow (current US$) in United Kingdom in 2000?
Make the answer very short. 1.02e+08. What is the difference between the Aid flow (current US$) of European Union in 1997 and the Aid flow (current US$) of United States in 2000?
Make the answer very short. 3.29e+07. What is the difference between the Aid flow (current US$) of European Union in 1997 and the Aid flow (current US$) of Iceland in 2000?
Give a very brief answer. 1.16e+08. What is the difference between the Aid flow (current US$) of United Kingdom in 1997 and the Aid flow (current US$) of United States in 2000?
Offer a terse response. -7.41e+07. What is the difference between the Aid flow (current US$) in United Kingdom in 1997 and the Aid flow (current US$) in Iceland in 2000?
Provide a succinct answer. 8.99e+06. What is the difference between the Aid flow (current US$) of United States in 1997 and the Aid flow (current US$) of Iceland in 2000?
Offer a very short reply. 7.42e+07. What is the difference between the Aid flow (current US$) in European Union in 1998 and the Aid flow (current US$) in United Kingdom in 1999?
Offer a very short reply. 7.08e+07. What is the difference between the Aid flow (current US$) of European Union in 1998 and the Aid flow (current US$) of United States in 1999?
Ensure brevity in your answer.  2.14e+07. What is the difference between the Aid flow (current US$) in European Union in 1998 and the Aid flow (current US$) in Iceland in 1999?
Ensure brevity in your answer.  8.07e+07. What is the difference between the Aid flow (current US$) of United Kingdom in 1998 and the Aid flow (current US$) of United States in 1999?
Give a very brief answer. -5.13e+07. What is the difference between the Aid flow (current US$) in United Kingdom in 1998 and the Aid flow (current US$) in Iceland in 1999?
Offer a terse response. 8.05e+06. What is the difference between the Aid flow (current US$) of United States in 1998 and the Aid flow (current US$) of Iceland in 1999?
Provide a short and direct response. 8.41e+07. What is the difference between the Aid flow (current US$) of European Union in 1998 and the Aid flow (current US$) of United Kingdom in 2000?
Make the answer very short. 6.68e+07. What is the difference between the Aid flow (current US$) in European Union in 1998 and the Aid flow (current US$) in United States in 2000?
Make the answer very short. -2.79e+06. What is the difference between the Aid flow (current US$) in European Union in 1998 and the Aid flow (current US$) in Iceland in 2000?
Ensure brevity in your answer.  8.03e+07. What is the difference between the Aid flow (current US$) in United Kingdom in 1998 and the Aid flow (current US$) in United States in 2000?
Make the answer very short. -7.54e+07. What is the difference between the Aid flow (current US$) of United Kingdom in 1998 and the Aid flow (current US$) of Iceland in 2000?
Give a very brief answer. 7.68e+06. What is the difference between the Aid flow (current US$) in United States in 1998 and the Aid flow (current US$) in Iceland in 2000?
Offer a very short reply. 8.37e+07. What is the difference between the Aid flow (current US$) in European Union in 1999 and the Aid flow (current US$) in United States in 2000?
Offer a very short reply. -6.97e+07. What is the difference between the Aid flow (current US$) of European Union in 1999 and the Aid flow (current US$) of Iceland in 2000?
Offer a very short reply. 1.34e+07. What is the difference between the Aid flow (current US$) in United Kingdom in 1999 and the Aid flow (current US$) in United States in 2000?
Your answer should be compact. -7.36e+07. What is the difference between the Aid flow (current US$) of United Kingdom in 1999 and the Aid flow (current US$) of Iceland in 2000?
Give a very brief answer. 9.51e+06. What is the difference between the Aid flow (current US$) in United States in 1999 and the Aid flow (current US$) in Iceland in 2000?
Make the answer very short. 5.89e+07. What is the average Aid flow (current US$) in European Union per year?
Provide a short and direct response. 7.86e+07. What is the average Aid flow (current US$) of United Kingdom per year?
Give a very brief answer. 8.60e+06. What is the average Aid flow (current US$) of United States per year?
Ensure brevity in your answer.  6.06e+07. What is the average Aid flow (current US$) of Iceland per year?
Offer a very short reply. 8.11e+05. In the year 1993, what is the difference between the Aid flow (current US$) in European Union and Aid flow (current US$) in United Kingdom?
Keep it short and to the point. 5.39e+07. In the year 1993, what is the difference between the Aid flow (current US$) in European Union and Aid flow (current US$) in United States?
Make the answer very short. 3.75e+07. In the year 1993, what is the difference between the Aid flow (current US$) in European Union and Aid flow (current US$) in Iceland?
Your response must be concise. 5.60e+07. In the year 1993, what is the difference between the Aid flow (current US$) in United Kingdom and Aid flow (current US$) in United States?
Your answer should be very brief. -1.64e+07. In the year 1993, what is the difference between the Aid flow (current US$) of United Kingdom and Aid flow (current US$) of Iceland?
Your response must be concise. 2.09e+06. In the year 1993, what is the difference between the Aid flow (current US$) of United States and Aid flow (current US$) of Iceland?
Make the answer very short. 1.85e+07. In the year 1994, what is the difference between the Aid flow (current US$) of European Union and Aid flow (current US$) of United Kingdom?
Your answer should be compact. 7.95e+07. In the year 1994, what is the difference between the Aid flow (current US$) of European Union and Aid flow (current US$) of United States?
Offer a very short reply. 2.51e+07. In the year 1994, what is the difference between the Aid flow (current US$) of European Union and Aid flow (current US$) of Iceland?
Provide a short and direct response. 8.88e+07. In the year 1994, what is the difference between the Aid flow (current US$) of United Kingdom and Aid flow (current US$) of United States?
Your answer should be very brief. -5.44e+07. In the year 1994, what is the difference between the Aid flow (current US$) in United Kingdom and Aid flow (current US$) in Iceland?
Your response must be concise. 9.30e+06. In the year 1994, what is the difference between the Aid flow (current US$) of United States and Aid flow (current US$) of Iceland?
Provide a short and direct response. 6.37e+07. In the year 1995, what is the difference between the Aid flow (current US$) of European Union and Aid flow (current US$) of United Kingdom?
Provide a succinct answer. 6.86e+07. In the year 1995, what is the difference between the Aid flow (current US$) of European Union and Aid flow (current US$) of United States?
Your answer should be very brief. 4.84e+07. In the year 1995, what is the difference between the Aid flow (current US$) of European Union and Aid flow (current US$) of Iceland?
Make the answer very short. 7.51e+07. In the year 1995, what is the difference between the Aid flow (current US$) of United Kingdom and Aid flow (current US$) of United States?
Your response must be concise. -2.02e+07. In the year 1995, what is the difference between the Aid flow (current US$) in United Kingdom and Aid flow (current US$) in Iceland?
Make the answer very short. 6.47e+06. In the year 1995, what is the difference between the Aid flow (current US$) of United States and Aid flow (current US$) of Iceland?
Offer a terse response. 2.67e+07. In the year 1996, what is the difference between the Aid flow (current US$) in European Union and Aid flow (current US$) in United Kingdom?
Give a very brief answer. 1.27e+08. In the year 1996, what is the difference between the Aid flow (current US$) of European Union and Aid flow (current US$) of United States?
Provide a short and direct response. 6.20e+07. In the year 1996, what is the difference between the Aid flow (current US$) of European Union and Aid flow (current US$) of Iceland?
Give a very brief answer. 1.31e+08. In the year 1996, what is the difference between the Aid flow (current US$) of United Kingdom and Aid flow (current US$) of United States?
Your answer should be very brief. -6.46e+07. In the year 1996, what is the difference between the Aid flow (current US$) in United Kingdom and Aid flow (current US$) in Iceland?
Provide a succinct answer. 3.95e+06. In the year 1996, what is the difference between the Aid flow (current US$) in United States and Aid flow (current US$) in Iceland?
Provide a succinct answer. 6.85e+07. In the year 1997, what is the difference between the Aid flow (current US$) of European Union and Aid flow (current US$) of United Kingdom?
Give a very brief answer. 1.07e+08. In the year 1997, what is the difference between the Aid flow (current US$) in European Union and Aid flow (current US$) in United States?
Your answer should be compact. 4.18e+07. In the year 1997, what is the difference between the Aid flow (current US$) in European Union and Aid flow (current US$) in Iceland?
Keep it short and to the point. 1.16e+08. In the year 1997, what is the difference between the Aid flow (current US$) in United Kingdom and Aid flow (current US$) in United States?
Your response must be concise. -6.52e+07. In the year 1997, what is the difference between the Aid flow (current US$) in United Kingdom and Aid flow (current US$) in Iceland?
Your answer should be very brief. 9.06e+06. In the year 1997, what is the difference between the Aid flow (current US$) of United States and Aid flow (current US$) of Iceland?
Keep it short and to the point. 7.43e+07. In the year 1998, what is the difference between the Aid flow (current US$) in European Union and Aid flow (current US$) in United Kingdom?
Provide a short and direct response. 7.26e+07. In the year 1998, what is the difference between the Aid flow (current US$) of European Union and Aid flow (current US$) of United States?
Provide a short and direct response. -3.38e+06. In the year 1998, what is the difference between the Aid flow (current US$) of European Union and Aid flow (current US$) of Iceland?
Offer a terse response. 8.06e+07. In the year 1998, what is the difference between the Aid flow (current US$) of United Kingdom and Aid flow (current US$) of United States?
Ensure brevity in your answer.  -7.60e+07. In the year 1998, what is the difference between the Aid flow (current US$) of United States and Aid flow (current US$) of Iceland?
Give a very brief answer. 8.40e+07. In the year 1999, what is the difference between the Aid flow (current US$) in European Union and Aid flow (current US$) in United Kingdom?
Keep it short and to the point. 3.87e+06. In the year 1999, what is the difference between the Aid flow (current US$) in European Union and Aid flow (current US$) in United States?
Your answer should be compact. -4.56e+07. In the year 1999, what is the difference between the Aid flow (current US$) in European Union and Aid flow (current US$) in Iceland?
Keep it short and to the point. 1.38e+07. In the year 1999, what is the difference between the Aid flow (current US$) of United Kingdom and Aid flow (current US$) of United States?
Ensure brevity in your answer.  -4.94e+07. In the year 1999, what is the difference between the Aid flow (current US$) in United Kingdom and Aid flow (current US$) in Iceland?
Offer a terse response. 9.88e+06. In the year 1999, what is the difference between the Aid flow (current US$) of United States and Aid flow (current US$) of Iceland?
Ensure brevity in your answer.  5.93e+07. In the year 2000, what is the difference between the Aid flow (current US$) of European Union and Aid flow (current US$) of United Kingdom?
Your response must be concise. 4.78e+07. In the year 2000, what is the difference between the Aid flow (current US$) of European Union and Aid flow (current US$) of United States?
Keep it short and to the point. -2.18e+07. In the year 2000, what is the difference between the Aid flow (current US$) of European Union and Aid flow (current US$) of Iceland?
Your answer should be very brief. 6.14e+07. In the year 2000, what is the difference between the Aid flow (current US$) in United Kingdom and Aid flow (current US$) in United States?
Give a very brief answer. -6.96e+07. In the year 2000, what is the difference between the Aid flow (current US$) in United Kingdom and Aid flow (current US$) in Iceland?
Make the answer very short. 1.35e+07. In the year 2000, what is the difference between the Aid flow (current US$) of United States and Aid flow (current US$) of Iceland?
Make the answer very short. 8.31e+07. What is the ratio of the Aid flow (current US$) in European Union in 1993 to that in 1994?
Your answer should be very brief. 0.63. What is the ratio of the Aid flow (current US$) of United Kingdom in 1993 to that in 1994?
Offer a very short reply. 0.27. What is the ratio of the Aid flow (current US$) in United States in 1993 to that in 1994?
Make the answer very short. 0.3. What is the ratio of the Aid flow (current US$) in Iceland in 1993 to that in 1994?
Your answer should be compact. 1.56. What is the ratio of the Aid flow (current US$) of European Union in 1993 to that in 1995?
Your answer should be compact. 0.75. What is the ratio of the Aid flow (current US$) in United Kingdom in 1993 to that in 1995?
Your response must be concise. 0.38. What is the ratio of the Aid flow (current US$) in United States in 1993 to that in 1995?
Your answer should be compact. 0.7. What is the ratio of the Aid flow (current US$) in Iceland in 1993 to that in 1995?
Your answer should be compact. 1.72. What is the ratio of the Aid flow (current US$) of European Union in 1993 to that in 1996?
Your answer should be very brief. 0.43. What is the ratio of the Aid flow (current US$) of United Kingdom in 1993 to that in 1996?
Ensure brevity in your answer.  0.48. What is the ratio of the Aid flow (current US$) in United States in 1993 to that in 1996?
Ensure brevity in your answer.  0.27. What is the ratio of the Aid flow (current US$) of Iceland in 1993 to that in 1996?
Offer a very short reply. 0.34. What is the ratio of the Aid flow (current US$) in European Union in 1993 to that in 1997?
Provide a short and direct response. 0.48. What is the ratio of the Aid flow (current US$) in United Kingdom in 1993 to that in 1997?
Ensure brevity in your answer.  0.25. What is the ratio of the Aid flow (current US$) of United States in 1993 to that in 1997?
Offer a terse response. 0.25. What is the ratio of the Aid flow (current US$) of Iceland in 1993 to that in 1997?
Make the answer very short. 0.45. What is the ratio of the Aid flow (current US$) of European Union in 1993 to that in 1998?
Keep it short and to the point. 0.69. What is the ratio of the Aid flow (current US$) in United Kingdom in 1993 to that in 1998?
Your answer should be compact. 0.29. What is the ratio of the Aid flow (current US$) of United States in 1993 to that in 1998?
Provide a succinct answer. 0.22. What is the ratio of the Aid flow (current US$) of Iceland in 1993 to that in 1998?
Provide a succinct answer. 0.59. What is the ratio of the Aid flow (current US$) in European Union in 1993 to that in 1999?
Offer a terse response. 3.88. What is the ratio of the Aid flow (current US$) of United Kingdom in 1993 to that in 1999?
Make the answer very short. 0.24. What is the ratio of the Aid flow (current US$) in United States in 1993 to that in 1999?
Your response must be concise. 0.32. What is the ratio of the Aid flow (current US$) of European Union in 1993 to that in 2000?
Your answer should be very brief. 0.9. What is the ratio of the Aid flow (current US$) in United Kingdom in 1993 to that in 2000?
Offer a terse response. 0.18. What is the ratio of the Aid flow (current US$) of United States in 1993 to that in 2000?
Provide a short and direct response. 0.23. What is the ratio of the Aid flow (current US$) in Iceland in 1993 to that in 2000?
Your response must be concise. 0.43. What is the ratio of the Aid flow (current US$) of European Union in 1994 to that in 1995?
Make the answer very short. 1.18. What is the ratio of the Aid flow (current US$) in United Kingdom in 1994 to that in 1995?
Give a very brief answer. 1.42. What is the ratio of the Aid flow (current US$) of United States in 1994 to that in 1995?
Your response must be concise. 2.37. What is the ratio of the Aid flow (current US$) of Iceland in 1994 to that in 1995?
Your answer should be compact. 1.1. What is the ratio of the Aid flow (current US$) of European Union in 1994 to that in 1996?
Provide a short and direct response. 0.68. What is the ratio of the Aid flow (current US$) in United Kingdom in 1994 to that in 1996?
Offer a very short reply. 1.78. What is the ratio of the Aid flow (current US$) in United States in 1994 to that in 1996?
Your response must be concise. 0.91. What is the ratio of the Aid flow (current US$) of Iceland in 1994 to that in 1996?
Ensure brevity in your answer.  0.22. What is the ratio of the Aid flow (current US$) of European Union in 1994 to that in 1997?
Ensure brevity in your answer.  0.76. What is the ratio of the Aid flow (current US$) of United Kingdom in 1994 to that in 1997?
Keep it short and to the point. 0.95. What is the ratio of the Aid flow (current US$) in United States in 1994 to that in 1997?
Ensure brevity in your answer.  0.85. What is the ratio of the Aid flow (current US$) in Iceland in 1994 to that in 1997?
Make the answer very short. 0.29. What is the ratio of the Aid flow (current US$) in European Union in 1994 to that in 1998?
Your answer should be very brief. 1.09. What is the ratio of the Aid flow (current US$) in United Kingdom in 1994 to that in 1998?
Give a very brief answer. 1.09. What is the ratio of the Aid flow (current US$) of United States in 1994 to that in 1998?
Offer a terse response. 0.75. What is the ratio of the Aid flow (current US$) in Iceland in 1994 to that in 1998?
Make the answer very short. 0.38. What is the ratio of the Aid flow (current US$) in European Union in 1994 to that in 1999?
Provide a short and direct response. 6.13. What is the ratio of the Aid flow (current US$) of United Kingdom in 1994 to that in 1999?
Provide a short and direct response. 0.9. What is the ratio of the Aid flow (current US$) in United States in 1994 to that in 1999?
Ensure brevity in your answer.  1.06. What is the ratio of the Aid flow (current US$) of European Union in 1994 to that in 2000?
Provide a succinct answer. 1.43. What is the ratio of the Aid flow (current US$) in United Kingdom in 1994 to that in 2000?
Keep it short and to the point. 0.65. What is the ratio of the Aid flow (current US$) of United States in 1994 to that in 2000?
Your response must be concise. 0.76. What is the ratio of the Aid flow (current US$) of Iceland in 1994 to that in 2000?
Your response must be concise. 0.27. What is the ratio of the Aid flow (current US$) in European Union in 1995 to that in 1996?
Your response must be concise. 0.57. What is the ratio of the Aid flow (current US$) in United Kingdom in 1995 to that in 1996?
Your answer should be compact. 1.25. What is the ratio of the Aid flow (current US$) of United States in 1995 to that in 1996?
Your response must be concise. 0.39. What is the ratio of the Aid flow (current US$) of Iceland in 1995 to that in 1996?
Ensure brevity in your answer.  0.2. What is the ratio of the Aid flow (current US$) in European Union in 1995 to that in 1997?
Offer a terse response. 0.64. What is the ratio of the Aid flow (current US$) in United Kingdom in 1995 to that in 1997?
Provide a succinct answer. 0.67. What is the ratio of the Aid flow (current US$) in United States in 1995 to that in 1997?
Give a very brief answer. 0.36. What is the ratio of the Aid flow (current US$) in Iceland in 1995 to that in 1997?
Your answer should be compact. 0.26. What is the ratio of the Aid flow (current US$) of European Union in 1995 to that in 1998?
Your answer should be very brief. 0.93. What is the ratio of the Aid flow (current US$) of United Kingdom in 1995 to that in 1998?
Make the answer very short. 0.76. What is the ratio of the Aid flow (current US$) of United States in 1995 to that in 1998?
Provide a succinct answer. 0.32. What is the ratio of the Aid flow (current US$) of Iceland in 1995 to that in 1998?
Provide a succinct answer. 0.34. What is the ratio of the Aid flow (current US$) of European Union in 1995 to that in 1999?
Provide a short and direct response. 5.18. What is the ratio of the Aid flow (current US$) in United Kingdom in 1995 to that in 1999?
Your answer should be very brief. 0.63. What is the ratio of the Aid flow (current US$) in United States in 1995 to that in 1999?
Your response must be concise. 0.45. What is the ratio of the Aid flow (current US$) in Iceland in 1995 to that in 1999?
Give a very brief answer. 0.36. What is the ratio of the Aid flow (current US$) of European Union in 1995 to that in 2000?
Ensure brevity in your answer.  1.21. What is the ratio of the Aid flow (current US$) in United Kingdom in 1995 to that in 2000?
Your answer should be compact. 0.46. What is the ratio of the Aid flow (current US$) in United States in 1995 to that in 2000?
Ensure brevity in your answer.  0.32. What is the ratio of the Aid flow (current US$) of Iceland in 1995 to that in 2000?
Provide a succinct answer. 0.25. What is the ratio of the Aid flow (current US$) in European Union in 1996 to that in 1997?
Keep it short and to the point. 1.13. What is the ratio of the Aid flow (current US$) in United Kingdom in 1996 to that in 1997?
Give a very brief answer. 0.53. What is the ratio of the Aid flow (current US$) in United States in 1996 to that in 1997?
Provide a succinct answer. 0.93. What is the ratio of the Aid flow (current US$) in Iceland in 1996 to that in 1997?
Your answer should be compact. 1.33. What is the ratio of the Aid flow (current US$) in European Union in 1996 to that in 1998?
Provide a succinct answer. 1.62. What is the ratio of the Aid flow (current US$) in United Kingdom in 1996 to that in 1998?
Provide a short and direct response. 0.61. What is the ratio of the Aid flow (current US$) of United States in 1996 to that in 1998?
Make the answer very short. 0.82. What is the ratio of the Aid flow (current US$) in Iceland in 1996 to that in 1998?
Offer a terse response. 1.72. What is the ratio of the Aid flow (current US$) of European Union in 1996 to that in 1999?
Your response must be concise. 9.07. What is the ratio of the Aid flow (current US$) in United Kingdom in 1996 to that in 1999?
Offer a very short reply. 0.51. What is the ratio of the Aid flow (current US$) in United States in 1996 to that in 1999?
Your answer should be compact. 1.16. What is the ratio of the Aid flow (current US$) of Iceland in 1996 to that in 1999?
Your answer should be very brief. 1.82. What is the ratio of the Aid flow (current US$) of European Union in 1996 to that in 2000?
Offer a terse response. 2.11. What is the ratio of the Aid flow (current US$) in United Kingdom in 1996 to that in 2000?
Ensure brevity in your answer.  0.37. What is the ratio of the Aid flow (current US$) of United States in 1996 to that in 2000?
Keep it short and to the point. 0.83. What is the ratio of the Aid flow (current US$) of Iceland in 1996 to that in 2000?
Offer a terse response. 1.25. What is the ratio of the Aid flow (current US$) in European Union in 1997 to that in 1998?
Your answer should be compact. 1.44. What is the ratio of the Aid flow (current US$) of United Kingdom in 1997 to that in 1998?
Give a very brief answer. 1.15. What is the ratio of the Aid flow (current US$) in United States in 1997 to that in 1998?
Provide a succinct answer. 0.89. What is the ratio of the Aid flow (current US$) in Iceland in 1997 to that in 1998?
Make the answer very short. 1.29. What is the ratio of the Aid flow (current US$) in European Union in 1997 to that in 1999?
Your response must be concise. 8.05. What is the ratio of the Aid flow (current US$) in United Kingdom in 1997 to that in 1999?
Offer a terse response. 0.95. What is the ratio of the Aid flow (current US$) of United States in 1997 to that in 1999?
Provide a succinct answer. 1.25. What is the ratio of the Aid flow (current US$) of Iceland in 1997 to that in 1999?
Make the answer very short. 1.38. What is the ratio of the Aid flow (current US$) in European Union in 1997 to that in 2000?
Your answer should be very brief. 1.87. What is the ratio of the Aid flow (current US$) of United Kingdom in 1997 to that in 2000?
Ensure brevity in your answer.  0.69. What is the ratio of the Aid flow (current US$) in United States in 1997 to that in 2000?
Offer a terse response. 0.89. What is the ratio of the Aid flow (current US$) of Iceland in 1997 to that in 2000?
Your answer should be compact. 0.94. What is the ratio of the Aid flow (current US$) in European Union in 1998 to that in 1999?
Ensure brevity in your answer.  5.6. What is the ratio of the Aid flow (current US$) of United Kingdom in 1998 to that in 1999?
Your answer should be compact. 0.83. What is the ratio of the Aid flow (current US$) in United States in 1998 to that in 1999?
Provide a short and direct response. 1.41. What is the ratio of the Aid flow (current US$) of European Union in 1998 to that in 2000?
Keep it short and to the point. 1.3. What is the ratio of the Aid flow (current US$) of United Kingdom in 1998 to that in 2000?
Offer a very short reply. 0.6. What is the ratio of the Aid flow (current US$) in United States in 1998 to that in 2000?
Keep it short and to the point. 1.01. What is the ratio of the Aid flow (current US$) in Iceland in 1998 to that in 2000?
Your answer should be very brief. 0.73. What is the ratio of the Aid flow (current US$) in European Union in 1999 to that in 2000?
Ensure brevity in your answer.  0.23. What is the ratio of the Aid flow (current US$) of United Kingdom in 1999 to that in 2000?
Offer a terse response. 0.73. What is the ratio of the Aid flow (current US$) of United States in 1999 to that in 2000?
Provide a succinct answer. 0.71. What is the ratio of the Aid flow (current US$) of Iceland in 1999 to that in 2000?
Offer a terse response. 0.68. What is the difference between the highest and the second highest Aid flow (current US$) of European Union?
Give a very brief answer. 1.49e+07. What is the difference between the highest and the second highest Aid flow (current US$) of United Kingdom?
Your response must be concise. 4.01e+06. What is the difference between the highest and the second highest Aid flow (current US$) of United States?
Your response must be concise. 5.90e+05. What is the difference between the highest and the second highest Aid flow (current US$) of Iceland?
Provide a succinct answer. 2.90e+05. What is the difference between the highest and the lowest Aid flow (current US$) in European Union?
Your answer should be very brief. 1.17e+08. What is the difference between the highest and the lowest Aid flow (current US$) in United Kingdom?
Your answer should be very brief. 1.21e+07. What is the difference between the highest and the lowest Aid flow (current US$) of United States?
Provide a succinct answer. 6.59e+07. What is the difference between the highest and the lowest Aid flow (current US$) in Iceland?
Your answer should be very brief. 1.17e+06. 